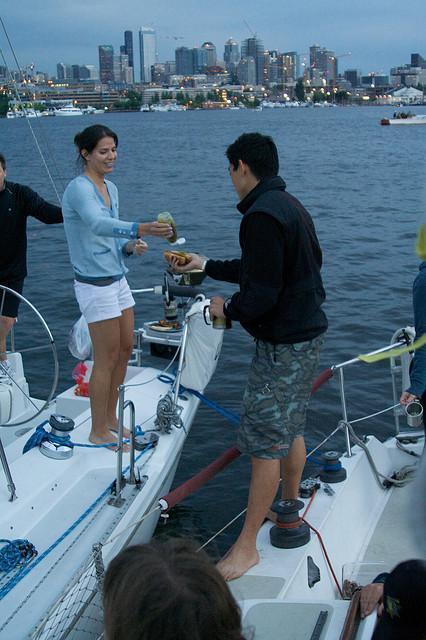What kind of sauce is this?
Select the accurate answer and provide justification: `Answer: choice
Rationale: srationale.`
Options: Hot sauce, relish, mustard, ketchup. Answer: relish.
Rationale: The condiment coming out of the bottle is green and is being put on a hotdog. 